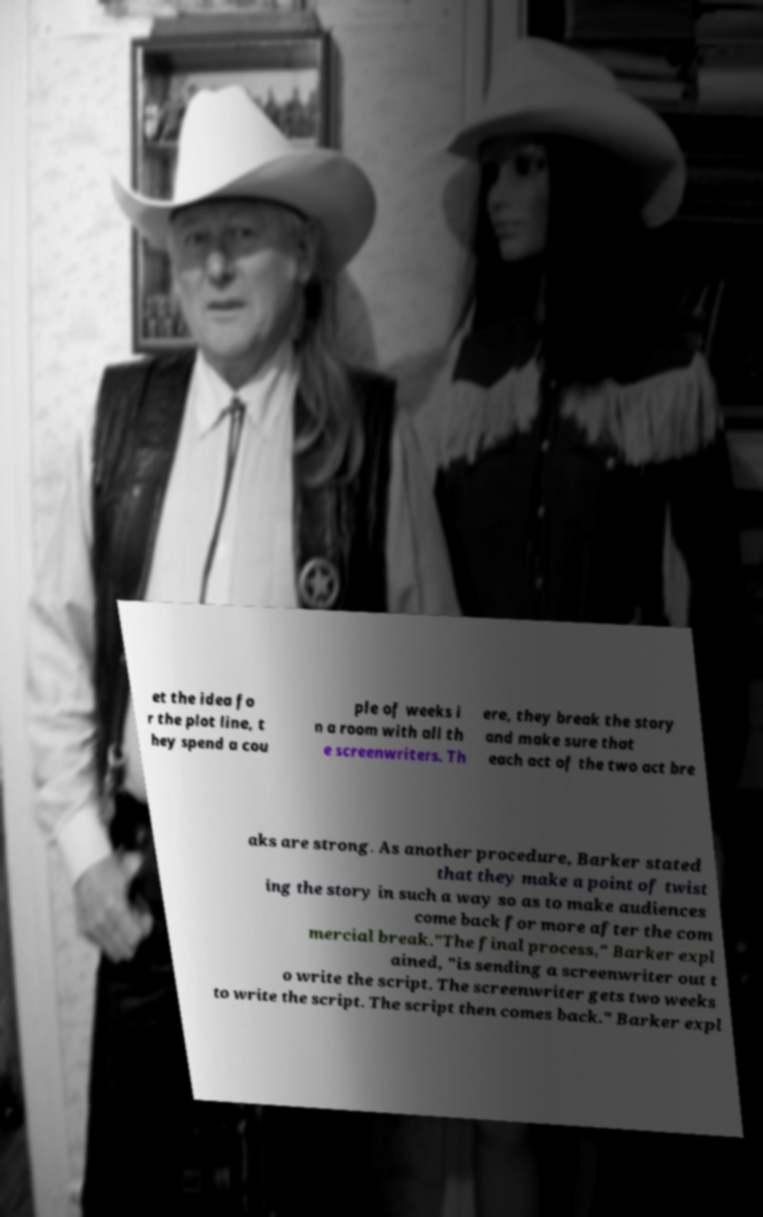Can you accurately transcribe the text from the provided image for me? et the idea fo r the plot line, t hey spend a cou ple of weeks i n a room with all th e screenwriters. Th ere, they break the story and make sure that each act of the two act bre aks are strong. As another procedure, Barker stated that they make a point of twist ing the story in such a way so as to make audiences come back for more after the com mercial break."The final process," Barker expl ained, "is sending a screenwriter out t o write the script. The screenwriter gets two weeks to write the script. The script then comes back." Barker expl 